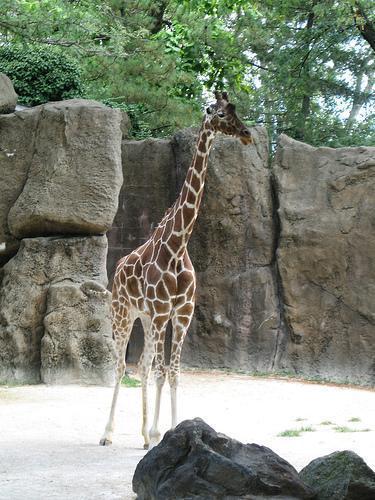How many animals are there?
Give a very brief answer. 1. 